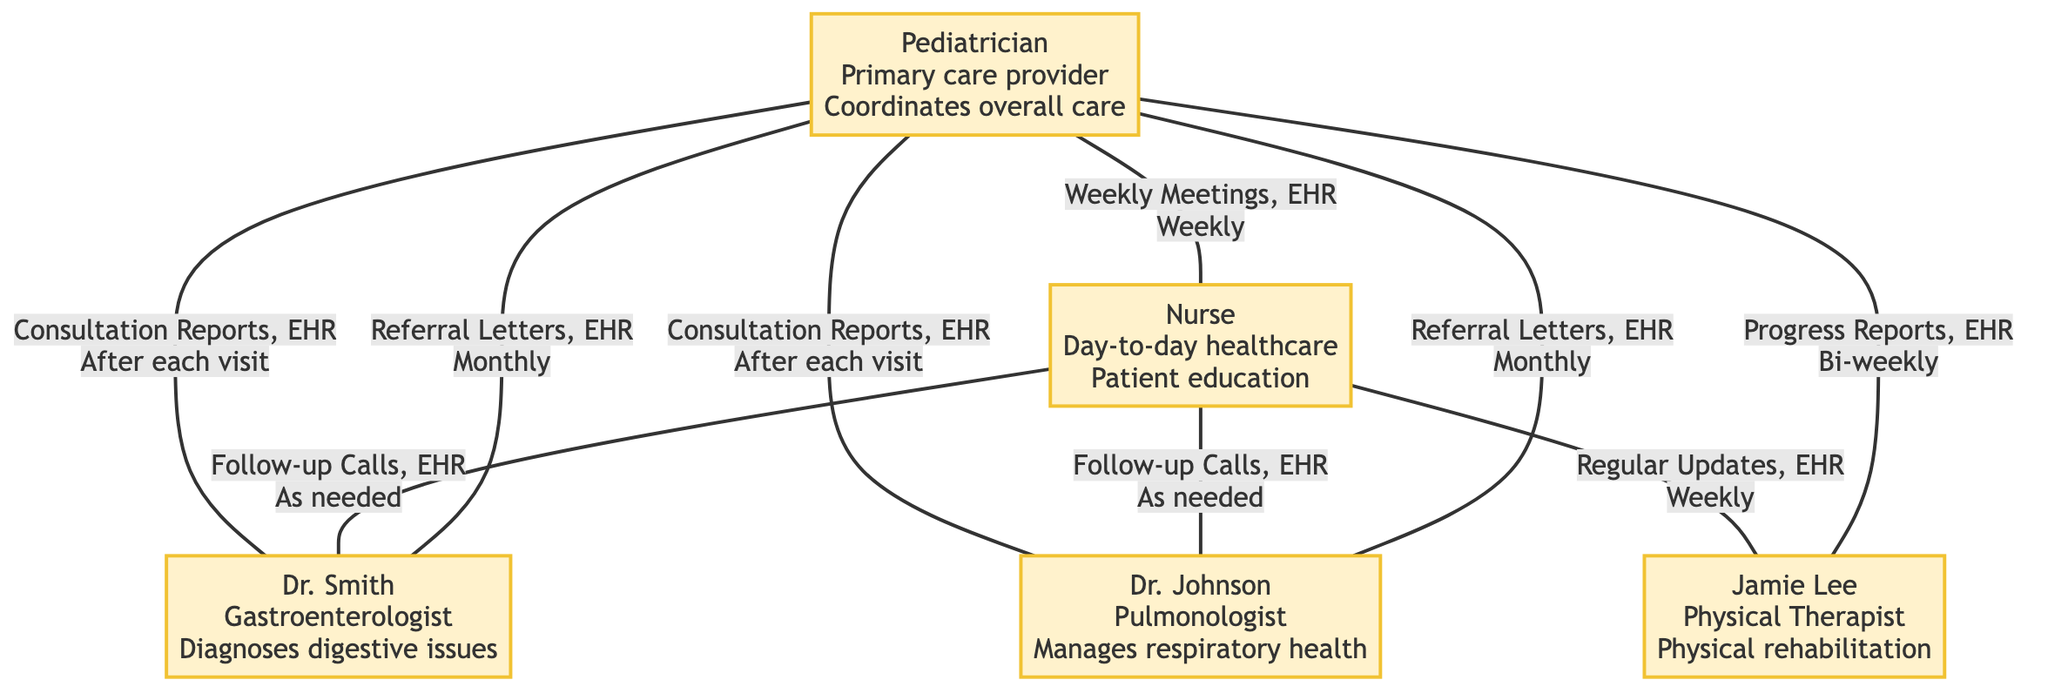What is the role of the Pediatrician? The Pediatrician is described as the "Primary care provider, coordinates overall care," which provides a clear indication of their responsibilities.
Answer: Primary care provider, coordinates overall care Who does Specialist1 connect with? The connections for Specialist1 (Dr. Smith) are listed as “Pediatrician” and “Nurse,” indicating they directly communicate with these two individuals.
Answer: Pediatrician, Nurse What method is used for communication between the Nurse and Therapist? The diagram states that the Nurse provides "Regular Updates, EHR Notes" for communication with the Therapist, which specifies the method of communication.
Answer: Regular Updates, EHR Notes How often does the Pediatrician meet with the Nurse? The frequency of communication between the Pediatrician and Nurse is indicated as “Weekly,” which specifies how often they interact.
Answer: Weekly What is the role of Specialist2? The role of Specialist2, Dr. Johnson, is defined as "Manages respiratory health," which indicates their function in the healthcare team.
Answer: Manages respiratory health Which communication method occurs after each visit of the Specialist? The diagram shows that “Consultation Reports, EHR” is the method used by Specialists to report back to the Pediatrician, clarifying the communication flow.
Answer: Consultation Reports, EHR What connections does the Nurse have with other team members? The Nurse connects with the Pediatrician, Specialist1, Specialist2, and Therapist as indicated in their connections, illustrating their extensive role within the care team.
Answer: Pediatrician, Specialist1, Specialist2, Therapist How often does the Pediatrician communicate with the Therapist? The frequency of communication between the Pediatrician and Therapist is listed as “Bi-weekly,” indicating the rate of their communication regarding patient progress.
Answer: Bi-weekly How many total professionals are represented in the diagram? The diagram illustrates five key professionals: Pediatrician, Specialist1, Specialist2, Nurse, and Therapist, leading to a simple tally of these roles for the total count.
Answer: Five 